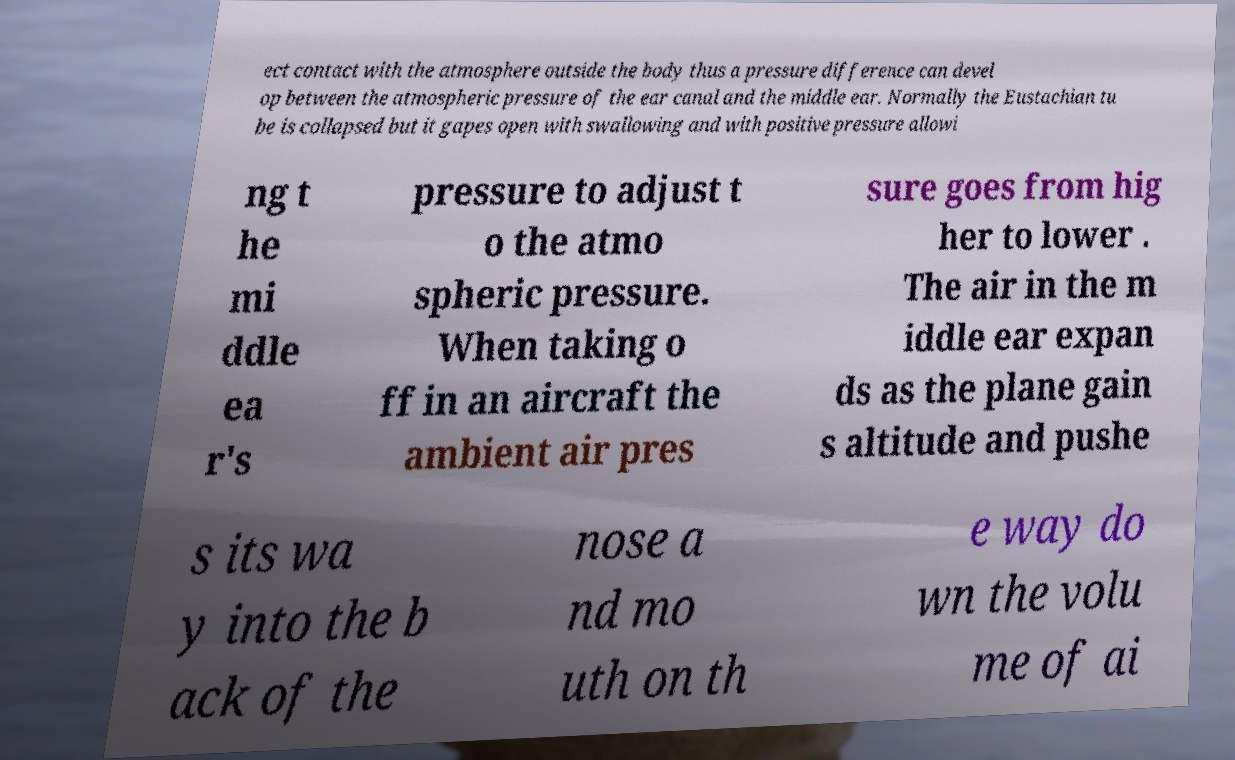For documentation purposes, I need the text within this image transcribed. Could you provide that? ect contact with the atmosphere outside the body thus a pressure difference can devel op between the atmospheric pressure of the ear canal and the middle ear. Normally the Eustachian tu be is collapsed but it gapes open with swallowing and with positive pressure allowi ng t he mi ddle ea r's pressure to adjust t o the atmo spheric pressure. When taking o ff in an aircraft the ambient air pres sure goes from hig her to lower . The air in the m iddle ear expan ds as the plane gain s altitude and pushe s its wa y into the b ack of the nose a nd mo uth on th e way do wn the volu me of ai 